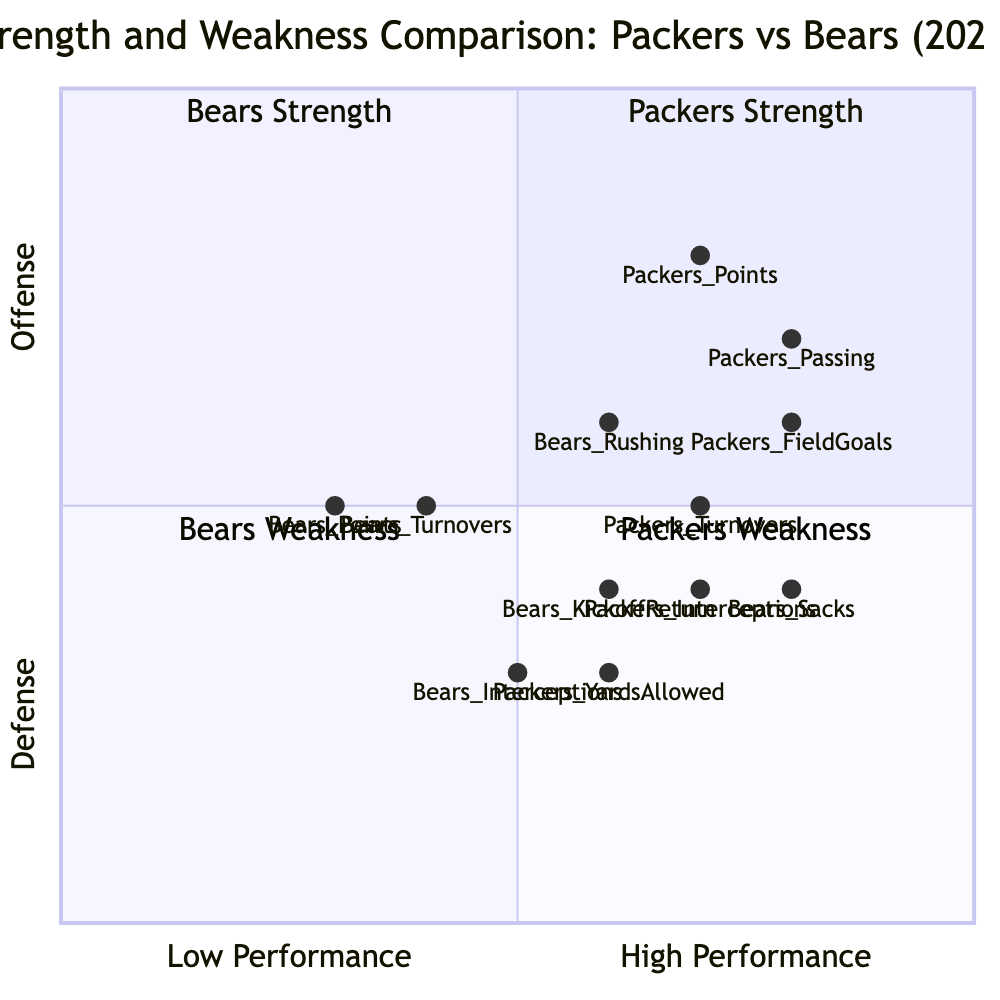What is the strength score for the Packers' passing game? The diagram shows that the strength score for the Packers' passing game is represented in quadrant 1, where its coordinates are [0.8, 0.7]. Therefore, the score for passing is 0.8.
Answer: 0.8 How do the Bears' rushing and the Packers' points compare in performance? In the diagram, the Bears' rushing score is [0.6, 0.6] and the Packers' points score is [0.7, 0.8]. Since the points score is higher than the rushing score for both axes, it indicates that the Packers' points are stronger than the Bears' rushing performance.
Answer: Packers' points are stronger What is the score for the Bears' interceptions? The diagram gives the score for the Bears' interceptions as [0.5, 0.3] which indicates their performance in both offensive and defensive aspects. The represented value is 0.5.
Answer: 0.5 Which quadrant represents the Bears' weakness in the diagram? The diagram shows that quadrant 3 represents the Bears' weakness, indicated by the coordinates which reflect lower scores on the axes.
Answer: Quadrant 3 What is the highest field goal efficiency score between the two teams? The Packers have a field goal efficiency score of [0.8, 0.6], while the Bears' corresponding score is not provided but represents lower efficiency. Therefore, the highest score is 0.8 for the Packers.
Answer: 0.8 How many turnovers did the Bears have compared to the Packers? According to the diagram, the Packers' turnovers are given as [0.7, 0.5] while the Bears' are [0.4, 0.5]. The first value for the Packers indicates a higher number of turnovers (0.7) than the Bears (0.4). Thus, the Packers had more turnovers.
Answer: Packers had more turnovers What represents the Packers' weakest aspect recorded in the diagram? The diagram indicates that the Packers' weakness is in quadrant 4, where they have relatively lower performance scores. Specifically, their defenses scored lower than their offensive scores.
Answer: Quadrant 4 Which team had better special teams efficiency? The diagram indicates that the Packers' field goal percentage is [0.8, 0.6], while the Bears' efficiency in special teams is represented through the kickoff return score of [0.6, 0.4]. The Packers have a higher scoring performance in special teams.
Answer: Packers had better efficiency 